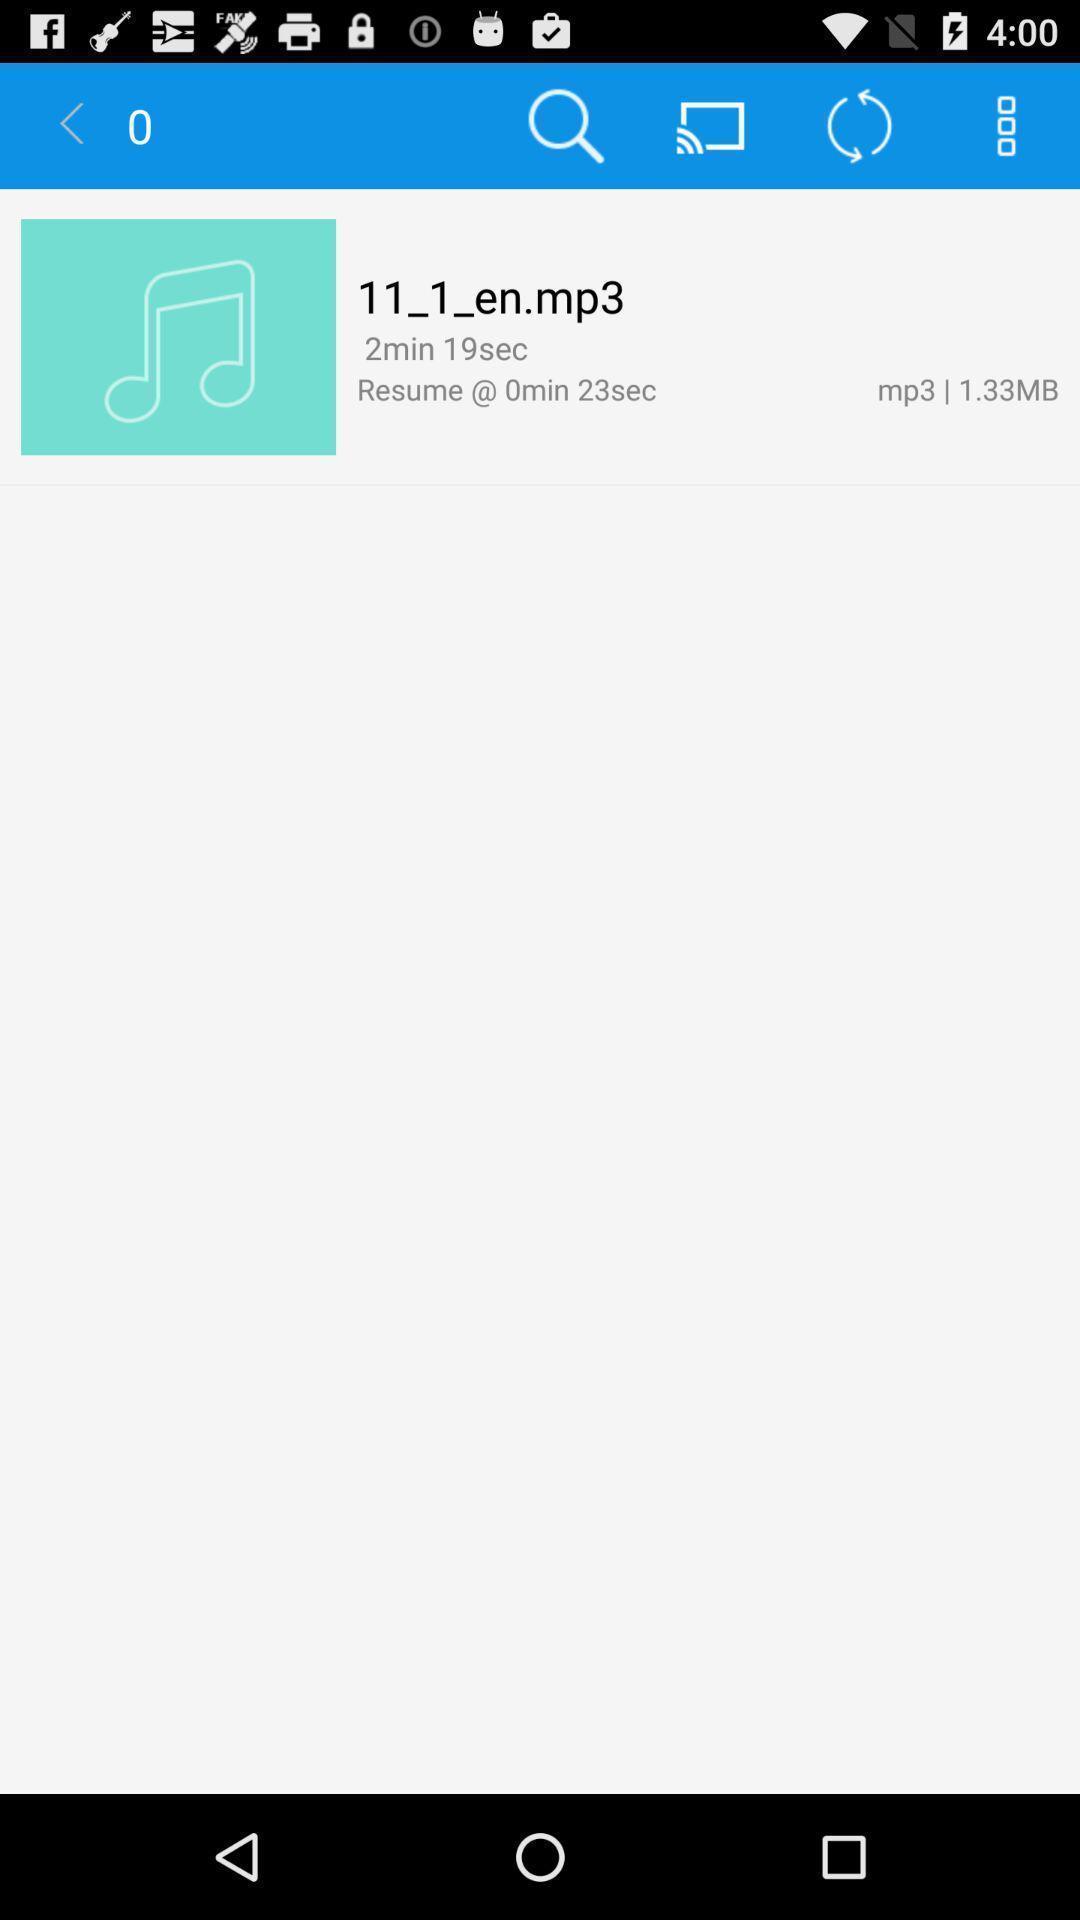What is the overall content of this screenshot? Song in a playlist of a music player. 